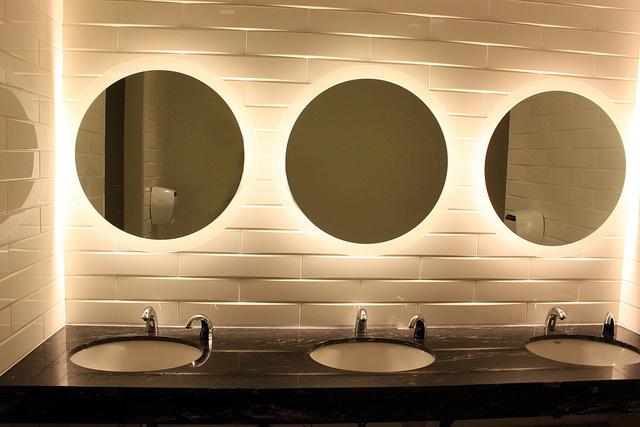Is there a hand dryer available?
Answer briefly. Yes. Is this inside a toilet?
Quick response, please. No. How many sinks are there?
Answer briefly. 3. 